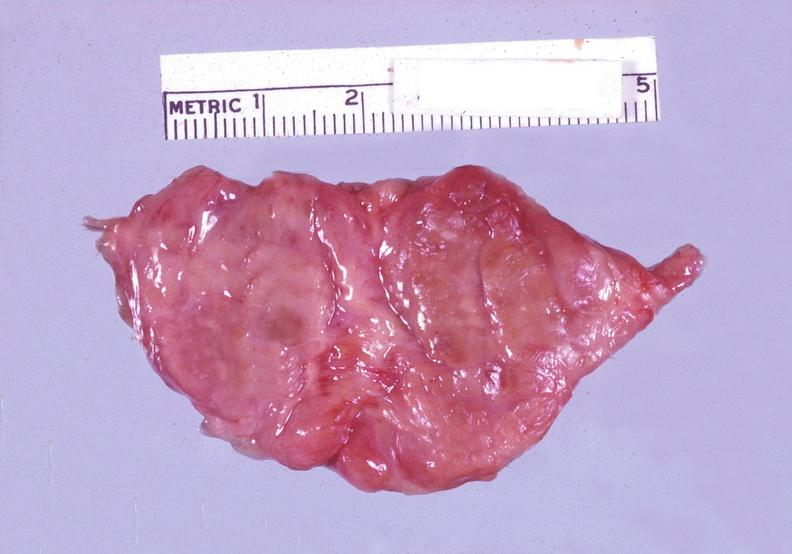what does this image show?
Answer the question using a single word or phrase. Thyroid 